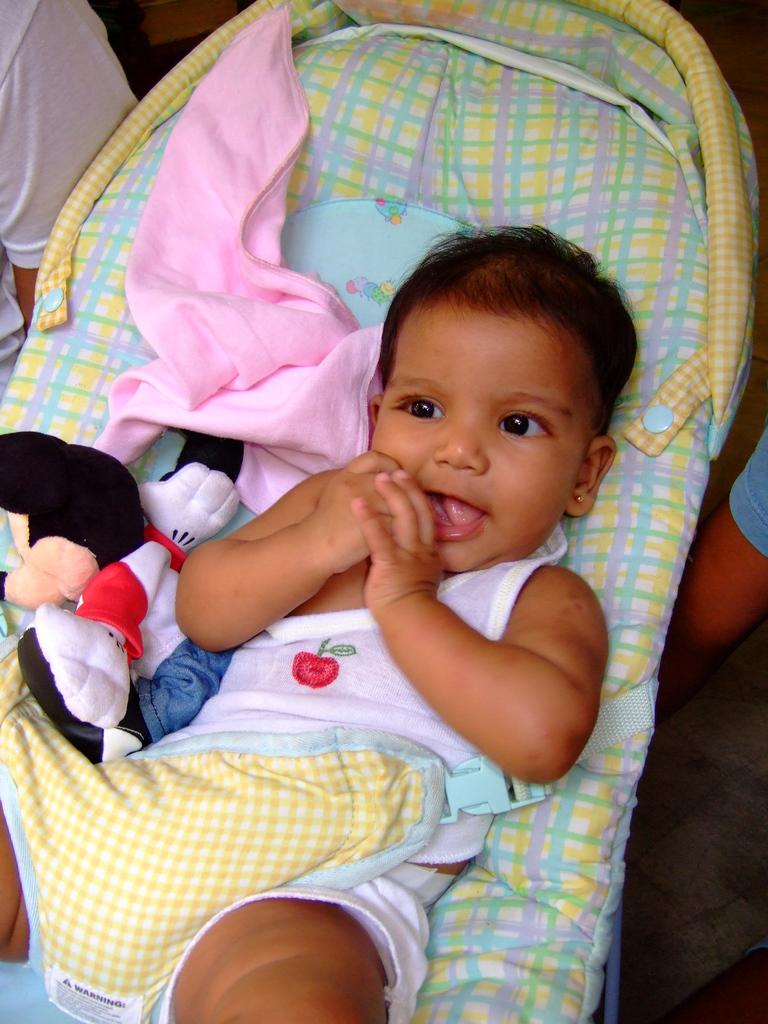What is the main subject in the center of the image? There is a baby wheelchair in the center of the image. What is covering the wheelchair? A cloth is present on the wheelchair. What is placed on the wheelchair with the baby? A toy is on the wheelchair. What is the baby's position in the image? There is a baby lying on the wheelchair. Can you describe the people in the background of the image? There are two persons in the background of the image. What type of cheese is being used as a pillow for the baby in the image? There is no cheese present in the image; the baby is lying on a cloth on the wheelchair. 